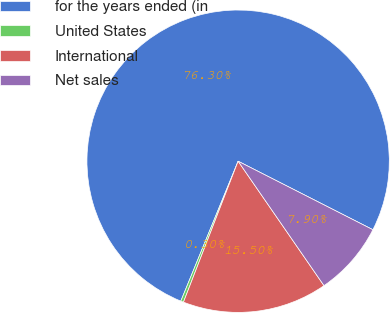Convert chart to OTSL. <chart><loc_0><loc_0><loc_500><loc_500><pie_chart><fcel>for the years ended (in<fcel>United States<fcel>International<fcel>Net sales<nl><fcel>76.29%<fcel>0.3%<fcel>15.5%<fcel>7.9%<nl></chart> 